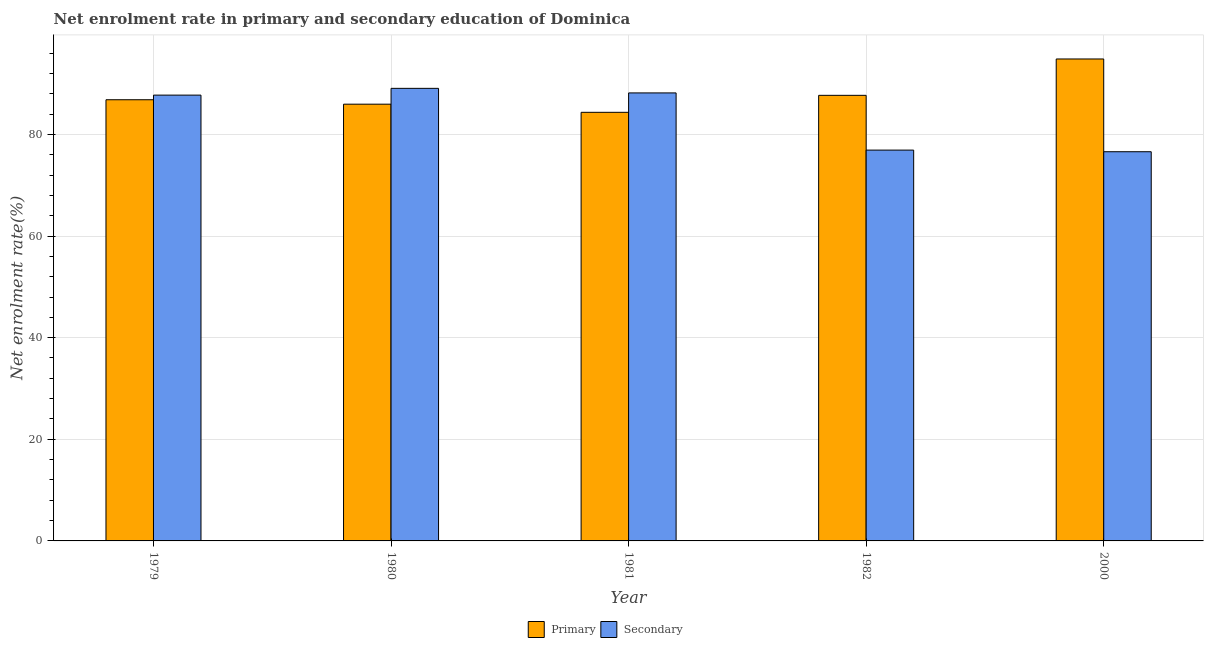Are the number of bars on each tick of the X-axis equal?
Ensure brevity in your answer.  Yes. How many bars are there on the 3rd tick from the left?
Provide a short and direct response. 2. In how many cases, is the number of bars for a given year not equal to the number of legend labels?
Your answer should be very brief. 0. What is the enrollment rate in primary education in 1980?
Give a very brief answer. 85.95. Across all years, what is the maximum enrollment rate in secondary education?
Your answer should be very brief. 89.07. Across all years, what is the minimum enrollment rate in secondary education?
Keep it short and to the point. 76.59. In which year was the enrollment rate in primary education maximum?
Your answer should be compact. 2000. In which year was the enrollment rate in secondary education minimum?
Offer a terse response. 2000. What is the total enrollment rate in secondary education in the graph?
Offer a very short reply. 418.47. What is the difference between the enrollment rate in primary education in 1979 and that in 2000?
Make the answer very short. -8.02. What is the difference between the enrollment rate in primary education in 1980 and the enrollment rate in secondary education in 1981?
Offer a very short reply. 1.6. What is the average enrollment rate in primary education per year?
Your response must be concise. 87.93. What is the ratio of the enrollment rate in primary education in 1981 to that in 2000?
Offer a terse response. 0.89. Is the enrollment rate in primary education in 1979 less than that in 1980?
Make the answer very short. No. Is the difference between the enrollment rate in primary education in 1980 and 2000 greater than the difference between the enrollment rate in secondary education in 1980 and 2000?
Keep it short and to the point. No. What is the difference between the highest and the second highest enrollment rate in primary education?
Provide a succinct answer. 7.16. What is the difference between the highest and the lowest enrollment rate in secondary education?
Offer a very short reply. 12.47. In how many years, is the enrollment rate in secondary education greater than the average enrollment rate in secondary education taken over all years?
Make the answer very short. 3. Is the sum of the enrollment rate in primary education in 1980 and 1981 greater than the maximum enrollment rate in secondary education across all years?
Give a very brief answer. Yes. What does the 1st bar from the left in 1979 represents?
Ensure brevity in your answer.  Primary. What does the 1st bar from the right in 1981 represents?
Your response must be concise. Secondary. How many bars are there?
Offer a terse response. 10. Are all the bars in the graph horizontal?
Ensure brevity in your answer.  No. How many legend labels are there?
Keep it short and to the point. 2. How are the legend labels stacked?
Make the answer very short. Horizontal. What is the title of the graph?
Your answer should be very brief. Net enrolment rate in primary and secondary education of Dominica. What is the label or title of the X-axis?
Offer a very short reply. Year. What is the label or title of the Y-axis?
Provide a succinct answer. Net enrolment rate(%). What is the Net enrolment rate(%) of Primary in 1979?
Your response must be concise. 86.82. What is the Net enrolment rate(%) of Secondary in 1979?
Offer a very short reply. 87.73. What is the Net enrolment rate(%) in Primary in 1980?
Your answer should be very brief. 85.95. What is the Net enrolment rate(%) in Secondary in 1980?
Your answer should be compact. 89.07. What is the Net enrolment rate(%) of Primary in 1981?
Give a very brief answer. 84.35. What is the Net enrolment rate(%) of Secondary in 1981?
Provide a short and direct response. 88.17. What is the Net enrolment rate(%) of Primary in 1982?
Keep it short and to the point. 87.69. What is the Net enrolment rate(%) in Secondary in 1982?
Your response must be concise. 76.91. What is the Net enrolment rate(%) of Primary in 2000?
Provide a short and direct response. 94.85. What is the Net enrolment rate(%) in Secondary in 2000?
Offer a terse response. 76.59. Across all years, what is the maximum Net enrolment rate(%) in Primary?
Offer a terse response. 94.85. Across all years, what is the maximum Net enrolment rate(%) in Secondary?
Provide a short and direct response. 89.07. Across all years, what is the minimum Net enrolment rate(%) of Primary?
Ensure brevity in your answer.  84.35. Across all years, what is the minimum Net enrolment rate(%) of Secondary?
Keep it short and to the point. 76.59. What is the total Net enrolment rate(%) of Primary in the graph?
Offer a very short reply. 439.66. What is the total Net enrolment rate(%) of Secondary in the graph?
Keep it short and to the point. 418.47. What is the difference between the Net enrolment rate(%) in Primary in 1979 and that in 1980?
Give a very brief answer. 0.87. What is the difference between the Net enrolment rate(%) of Secondary in 1979 and that in 1980?
Your response must be concise. -1.33. What is the difference between the Net enrolment rate(%) of Primary in 1979 and that in 1981?
Ensure brevity in your answer.  2.47. What is the difference between the Net enrolment rate(%) in Secondary in 1979 and that in 1981?
Give a very brief answer. -0.43. What is the difference between the Net enrolment rate(%) in Primary in 1979 and that in 1982?
Your answer should be compact. -0.87. What is the difference between the Net enrolment rate(%) in Secondary in 1979 and that in 1982?
Ensure brevity in your answer.  10.82. What is the difference between the Net enrolment rate(%) in Primary in 1979 and that in 2000?
Your response must be concise. -8.03. What is the difference between the Net enrolment rate(%) of Secondary in 1979 and that in 2000?
Give a very brief answer. 11.14. What is the difference between the Net enrolment rate(%) of Primary in 1980 and that in 1981?
Make the answer very short. 1.6. What is the difference between the Net enrolment rate(%) in Secondary in 1980 and that in 1981?
Your answer should be compact. 0.9. What is the difference between the Net enrolment rate(%) of Primary in 1980 and that in 1982?
Ensure brevity in your answer.  -1.74. What is the difference between the Net enrolment rate(%) in Secondary in 1980 and that in 1982?
Make the answer very short. 12.15. What is the difference between the Net enrolment rate(%) in Primary in 1980 and that in 2000?
Provide a succinct answer. -8.9. What is the difference between the Net enrolment rate(%) in Secondary in 1980 and that in 2000?
Give a very brief answer. 12.47. What is the difference between the Net enrolment rate(%) of Primary in 1981 and that in 1982?
Keep it short and to the point. -3.34. What is the difference between the Net enrolment rate(%) in Secondary in 1981 and that in 1982?
Offer a terse response. 11.25. What is the difference between the Net enrolment rate(%) of Primary in 1981 and that in 2000?
Your answer should be compact. -10.5. What is the difference between the Net enrolment rate(%) of Secondary in 1981 and that in 2000?
Ensure brevity in your answer.  11.57. What is the difference between the Net enrolment rate(%) of Primary in 1982 and that in 2000?
Your answer should be very brief. -7.16. What is the difference between the Net enrolment rate(%) in Secondary in 1982 and that in 2000?
Offer a terse response. 0.32. What is the difference between the Net enrolment rate(%) of Primary in 1979 and the Net enrolment rate(%) of Secondary in 1980?
Your answer should be compact. -2.24. What is the difference between the Net enrolment rate(%) of Primary in 1979 and the Net enrolment rate(%) of Secondary in 1981?
Give a very brief answer. -1.34. What is the difference between the Net enrolment rate(%) of Primary in 1979 and the Net enrolment rate(%) of Secondary in 1982?
Make the answer very short. 9.91. What is the difference between the Net enrolment rate(%) of Primary in 1979 and the Net enrolment rate(%) of Secondary in 2000?
Your answer should be compact. 10.23. What is the difference between the Net enrolment rate(%) of Primary in 1980 and the Net enrolment rate(%) of Secondary in 1981?
Ensure brevity in your answer.  -2.22. What is the difference between the Net enrolment rate(%) in Primary in 1980 and the Net enrolment rate(%) in Secondary in 1982?
Provide a succinct answer. 9.04. What is the difference between the Net enrolment rate(%) of Primary in 1980 and the Net enrolment rate(%) of Secondary in 2000?
Give a very brief answer. 9.36. What is the difference between the Net enrolment rate(%) of Primary in 1981 and the Net enrolment rate(%) of Secondary in 1982?
Keep it short and to the point. 7.43. What is the difference between the Net enrolment rate(%) of Primary in 1981 and the Net enrolment rate(%) of Secondary in 2000?
Offer a very short reply. 7.75. What is the difference between the Net enrolment rate(%) in Primary in 1982 and the Net enrolment rate(%) in Secondary in 2000?
Offer a very short reply. 11.1. What is the average Net enrolment rate(%) in Primary per year?
Provide a succinct answer. 87.93. What is the average Net enrolment rate(%) in Secondary per year?
Give a very brief answer. 83.69. In the year 1979, what is the difference between the Net enrolment rate(%) of Primary and Net enrolment rate(%) of Secondary?
Make the answer very short. -0.91. In the year 1980, what is the difference between the Net enrolment rate(%) in Primary and Net enrolment rate(%) in Secondary?
Offer a very short reply. -3.11. In the year 1981, what is the difference between the Net enrolment rate(%) in Primary and Net enrolment rate(%) in Secondary?
Your answer should be compact. -3.82. In the year 1982, what is the difference between the Net enrolment rate(%) in Primary and Net enrolment rate(%) in Secondary?
Offer a very short reply. 10.78. In the year 2000, what is the difference between the Net enrolment rate(%) of Primary and Net enrolment rate(%) of Secondary?
Your answer should be very brief. 18.25. What is the ratio of the Net enrolment rate(%) of Primary in 1979 to that in 1980?
Your answer should be compact. 1.01. What is the ratio of the Net enrolment rate(%) in Secondary in 1979 to that in 1980?
Provide a succinct answer. 0.99. What is the ratio of the Net enrolment rate(%) in Primary in 1979 to that in 1981?
Your response must be concise. 1.03. What is the ratio of the Net enrolment rate(%) of Secondary in 1979 to that in 1982?
Ensure brevity in your answer.  1.14. What is the ratio of the Net enrolment rate(%) of Primary in 1979 to that in 2000?
Your answer should be very brief. 0.92. What is the ratio of the Net enrolment rate(%) of Secondary in 1979 to that in 2000?
Your answer should be very brief. 1.15. What is the ratio of the Net enrolment rate(%) of Primary in 1980 to that in 1981?
Make the answer very short. 1.02. What is the ratio of the Net enrolment rate(%) in Secondary in 1980 to that in 1981?
Your answer should be compact. 1.01. What is the ratio of the Net enrolment rate(%) of Primary in 1980 to that in 1982?
Your answer should be compact. 0.98. What is the ratio of the Net enrolment rate(%) of Secondary in 1980 to that in 1982?
Offer a very short reply. 1.16. What is the ratio of the Net enrolment rate(%) in Primary in 1980 to that in 2000?
Keep it short and to the point. 0.91. What is the ratio of the Net enrolment rate(%) of Secondary in 1980 to that in 2000?
Your response must be concise. 1.16. What is the ratio of the Net enrolment rate(%) of Primary in 1981 to that in 1982?
Provide a succinct answer. 0.96. What is the ratio of the Net enrolment rate(%) of Secondary in 1981 to that in 1982?
Provide a succinct answer. 1.15. What is the ratio of the Net enrolment rate(%) of Primary in 1981 to that in 2000?
Provide a succinct answer. 0.89. What is the ratio of the Net enrolment rate(%) of Secondary in 1981 to that in 2000?
Keep it short and to the point. 1.15. What is the ratio of the Net enrolment rate(%) in Primary in 1982 to that in 2000?
Your response must be concise. 0.92. What is the difference between the highest and the second highest Net enrolment rate(%) of Primary?
Give a very brief answer. 7.16. What is the difference between the highest and the second highest Net enrolment rate(%) of Secondary?
Offer a terse response. 0.9. What is the difference between the highest and the lowest Net enrolment rate(%) in Primary?
Give a very brief answer. 10.5. What is the difference between the highest and the lowest Net enrolment rate(%) in Secondary?
Your answer should be very brief. 12.47. 